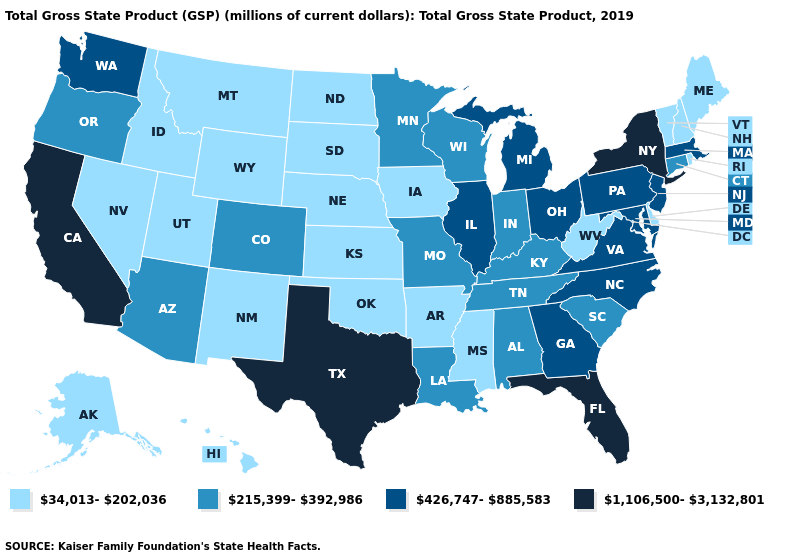Name the states that have a value in the range 1,106,500-3,132,801?
Be succinct. California, Florida, New York, Texas. Which states hav the highest value in the South?
Quick response, please. Florida, Texas. What is the lowest value in the MidWest?
Write a very short answer. 34,013-202,036. Among the states that border Oregon , which have the highest value?
Be succinct. California. Is the legend a continuous bar?
Answer briefly. No. What is the value of Mississippi?
Concise answer only. 34,013-202,036. What is the lowest value in the USA?
Give a very brief answer. 34,013-202,036. Among the states that border Pennsylvania , which have the lowest value?
Concise answer only. Delaware, West Virginia. Which states have the highest value in the USA?
Give a very brief answer. California, Florida, New York, Texas. Does New Hampshire have a lower value than Michigan?
Give a very brief answer. Yes. What is the value of New Hampshire?
Give a very brief answer. 34,013-202,036. Among the states that border Minnesota , does North Dakota have the lowest value?
Write a very short answer. Yes. What is the lowest value in the Northeast?
Give a very brief answer. 34,013-202,036. Which states have the lowest value in the USA?
Keep it brief. Alaska, Arkansas, Delaware, Hawaii, Idaho, Iowa, Kansas, Maine, Mississippi, Montana, Nebraska, Nevada, New Hampshire, New Mexico, North Dakota, Oklahoma, Rhode Island, South Dakota, Utah, Vermont, West Virginia, Wyoming. What is the highest value in the MidWest ?
Write a very short answer. 426,747-885,583. 